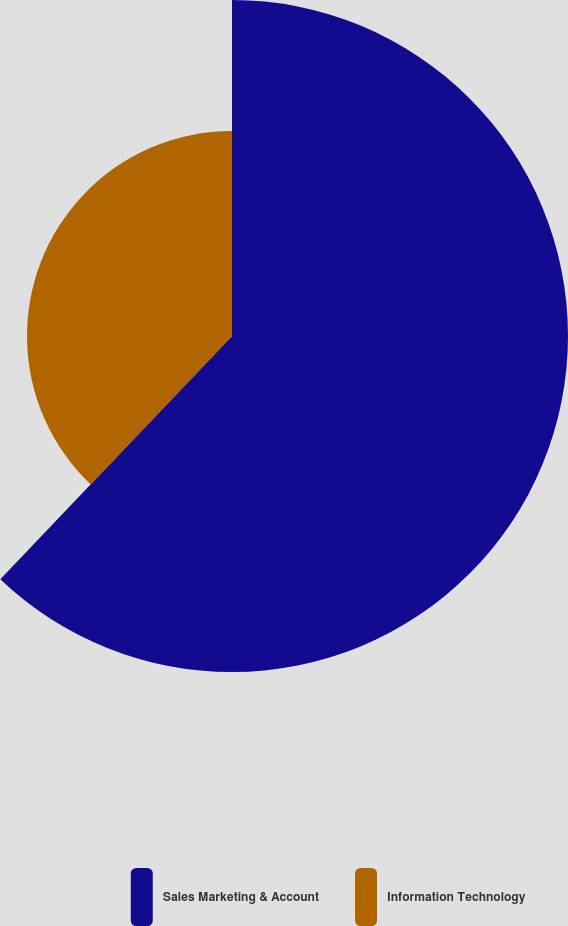<chart> <loc_0><loc_0><loc_500><loc_500><pie_chart><fcel>Sales Marketing & Account<fcel>Information Technology<nl><fcel>62.11%<fcel>37.89%<nl></chart> 